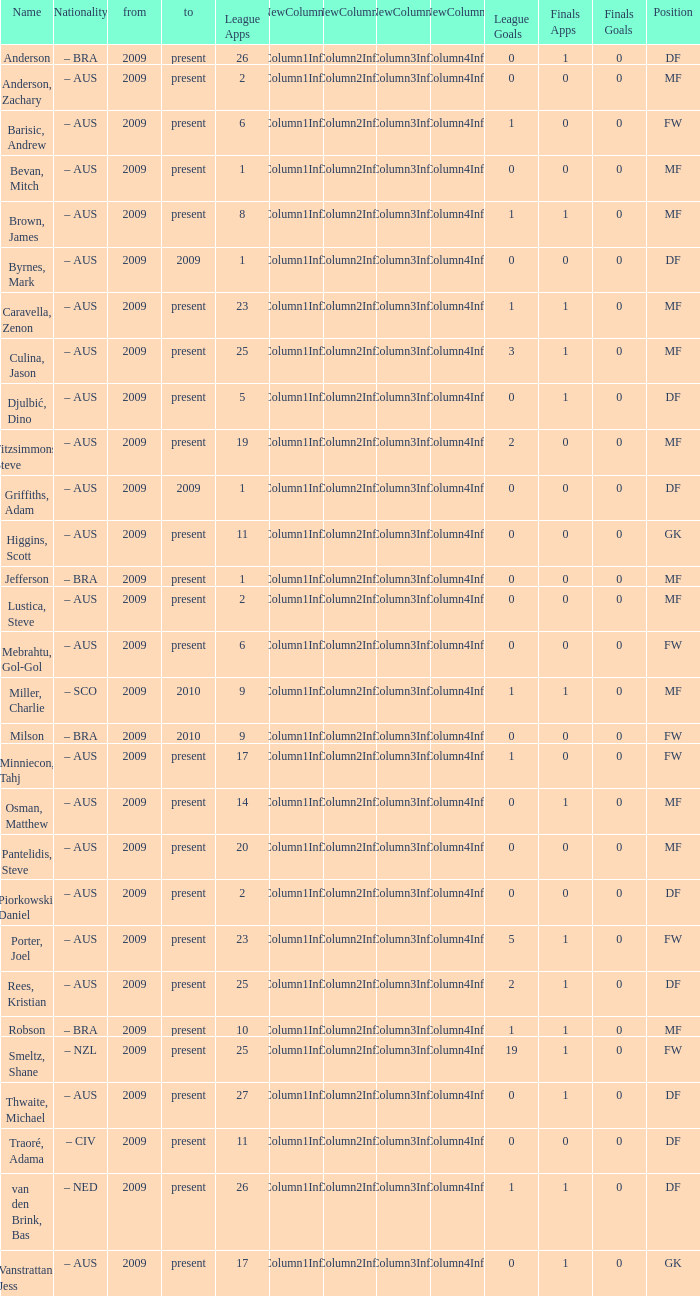Name the mosst finals apps 1.0. 